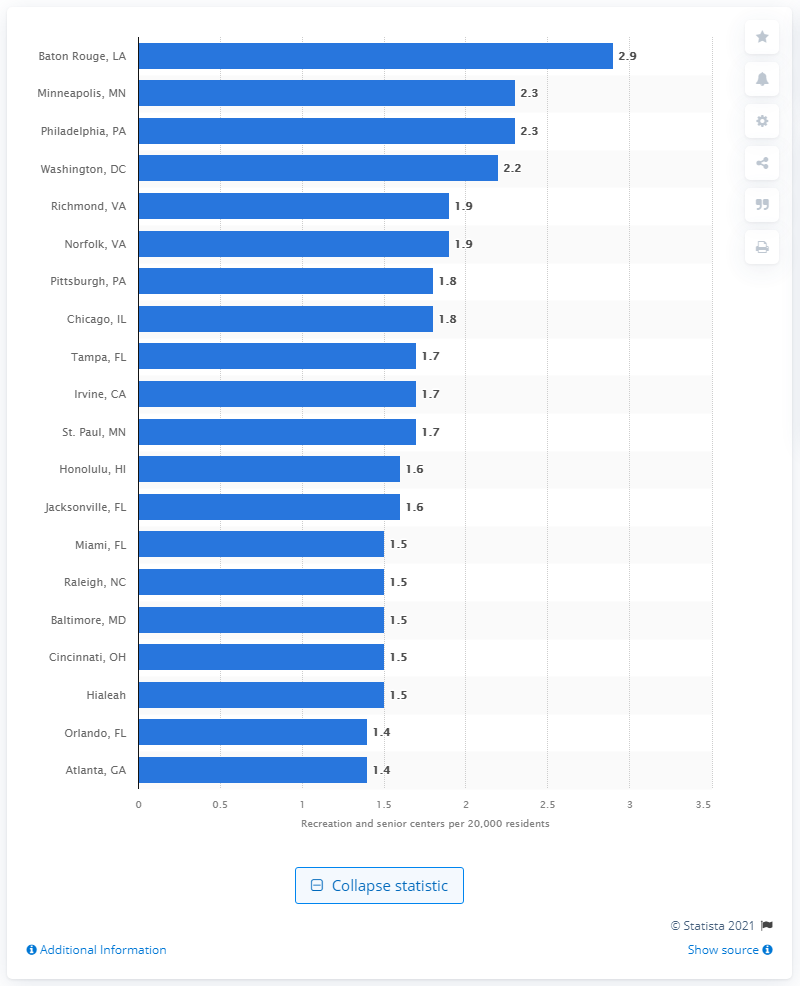Identify some key points in this picture. In 2020, there were 2.2 recreation and senior centers in Washington, D.C. 